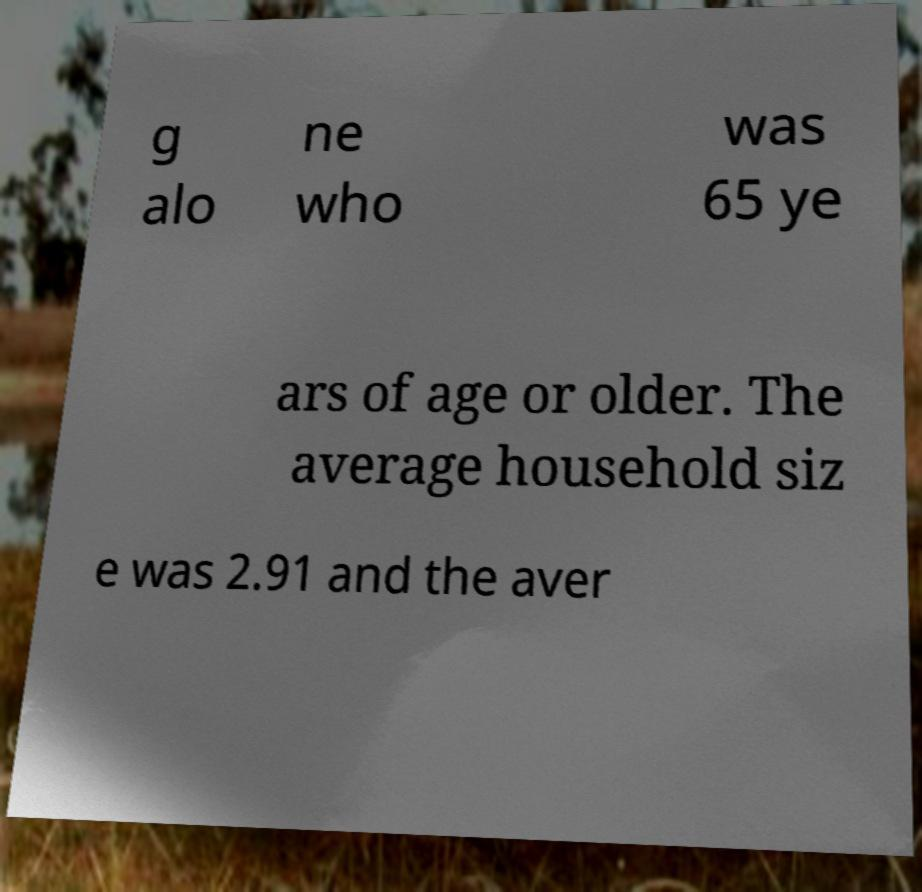Could you assist in decoding the text presented in this image and type it out clearly? g alo ne who was 65 ye ars of age or older. The average household siz e was 2.91 and the aver 